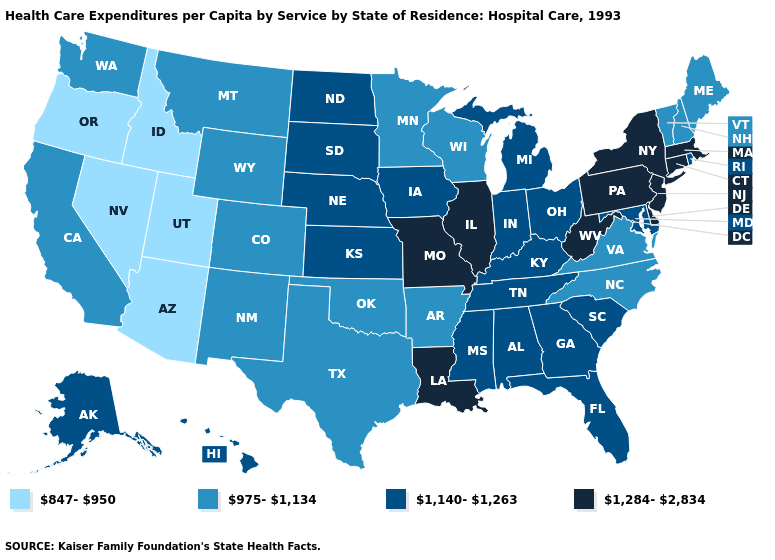Does the map have missing data?
Answer briefly. No. What is the highest value in states that border Iowa?
Be succinct. 1,284-2,834. Among the states that border Missouri , does Illinois have the highest value?
Be succinct. Yes. Name the states that have a value in the range 1,284-2,834?
Quick response, please. Connecticut, Delaware, Illinois, Louisiana, Massachusetts, Missouri, New Jersey, New York, Pennsylvania, West Virginia. What is the value of North Carolina?
Keep it brief. 975-1,134. What is the value of New Mexico?
Write a very short answer. 975-1,134. Name the states that have a value in the range 847-950?
Keep it brief. Arizona, Idaho, Nevada, Oregon, Utah. Does North Carolina have the highest value in the South?
Answer briefly. No. Is the legend a continuous bar?
Short answer required. No. What is the value of Wyoming?
Quick response, please. 975-1,134. Name the states that have a value in the range 1,284-2,834?
Keep it brief. Connecticut, Delaware, Illinois, Louisiana, Massachusetts, Missouri, New Jersey, New York, Pennsylvania, West Virginia. What is the lowest value in the USA?
Keep it brief. 847-950. What is the highest value in the MidWest ?
Give a very brief answer. 1,284-2,834. Among the states that border Wyoming , does Nebraska have the highest value?
Concise answer only. Yes. What is the lowest value in states that border Pennsylvania?
Concise answer only. 1,140-1,263. 